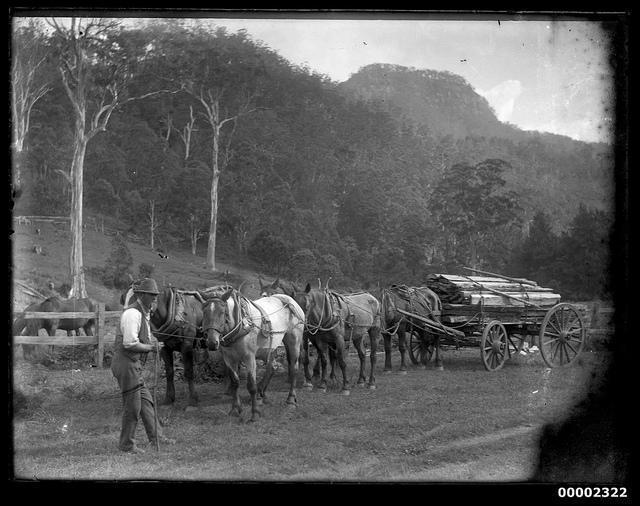How many wheels does the wagon have?
Give a very brief answer. 4. How many people are visible?
Give a very brief answer. 1. How many horses are in the picture?
Give a very brief answer. 4. How many cars have a surfboard on them?
Give a very brief answer. 0. 